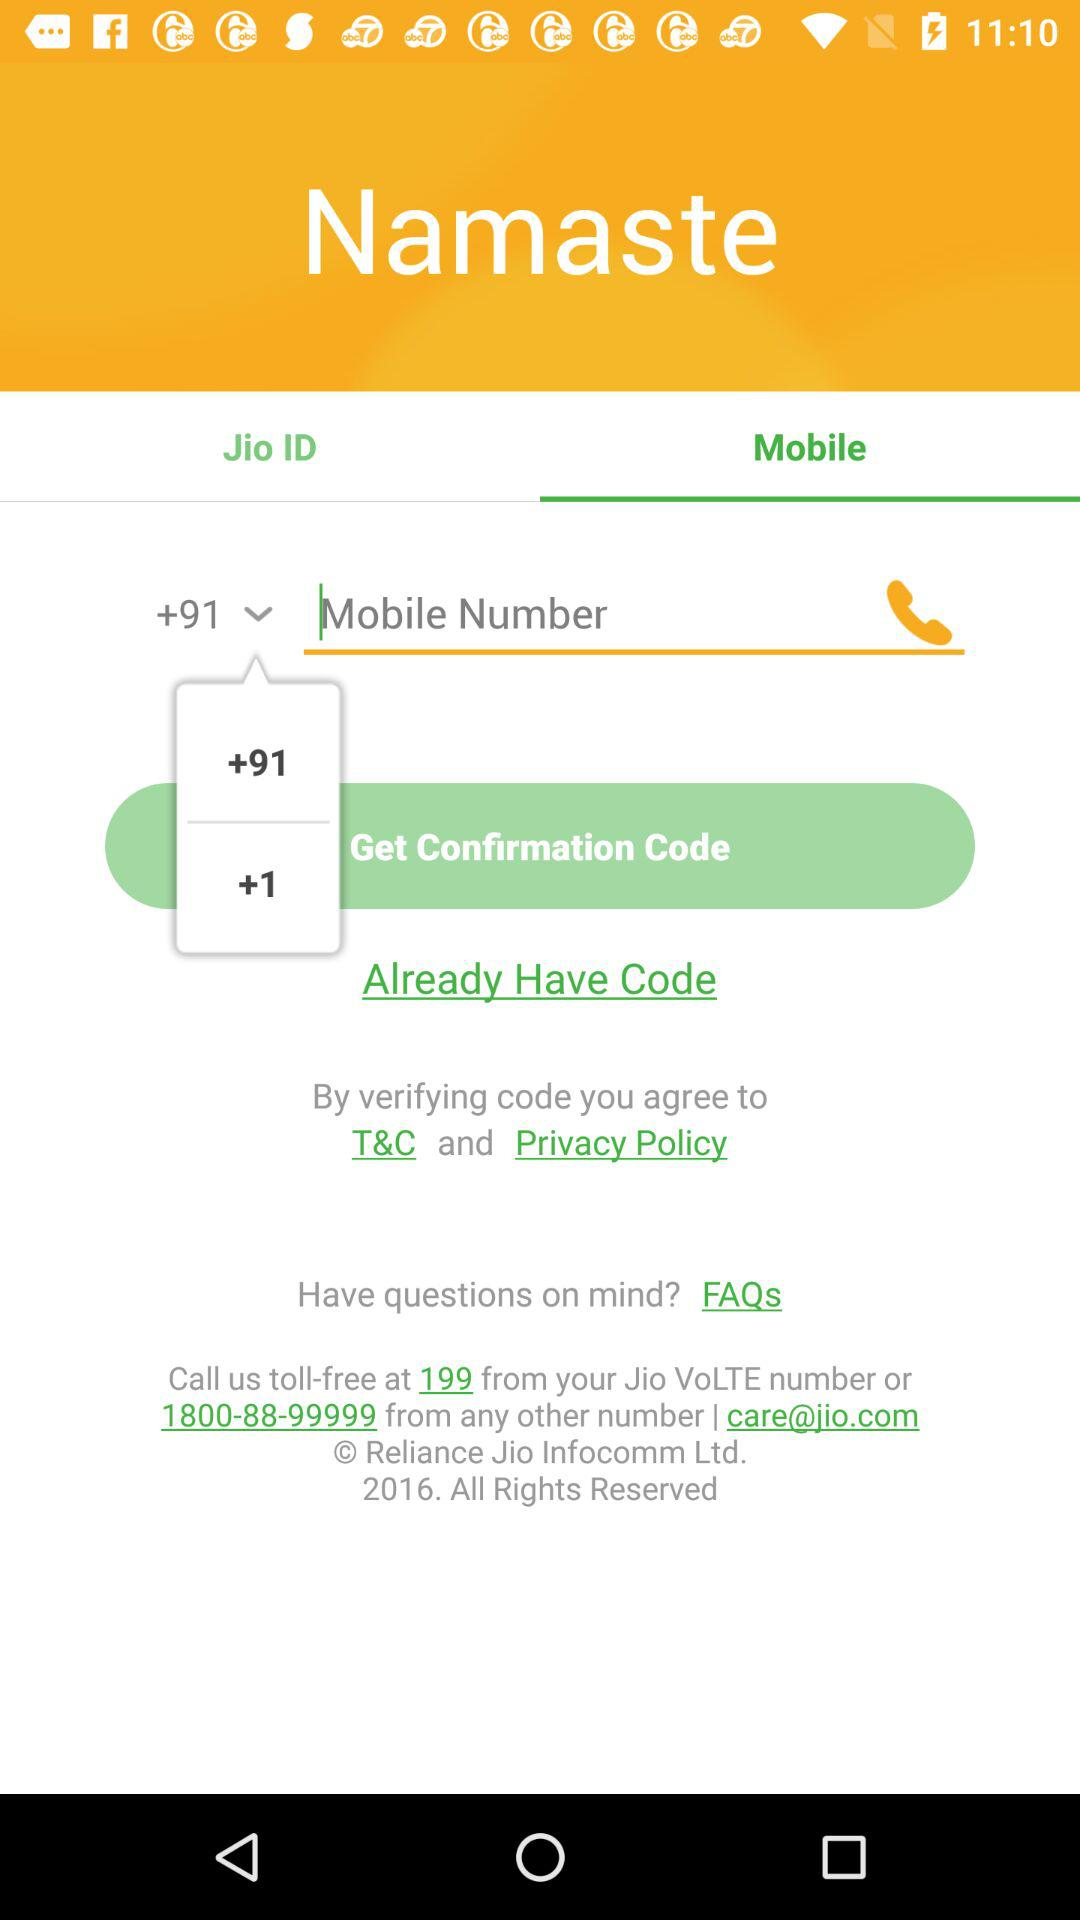Which tab is selected? The selected tab is "Mobile". 